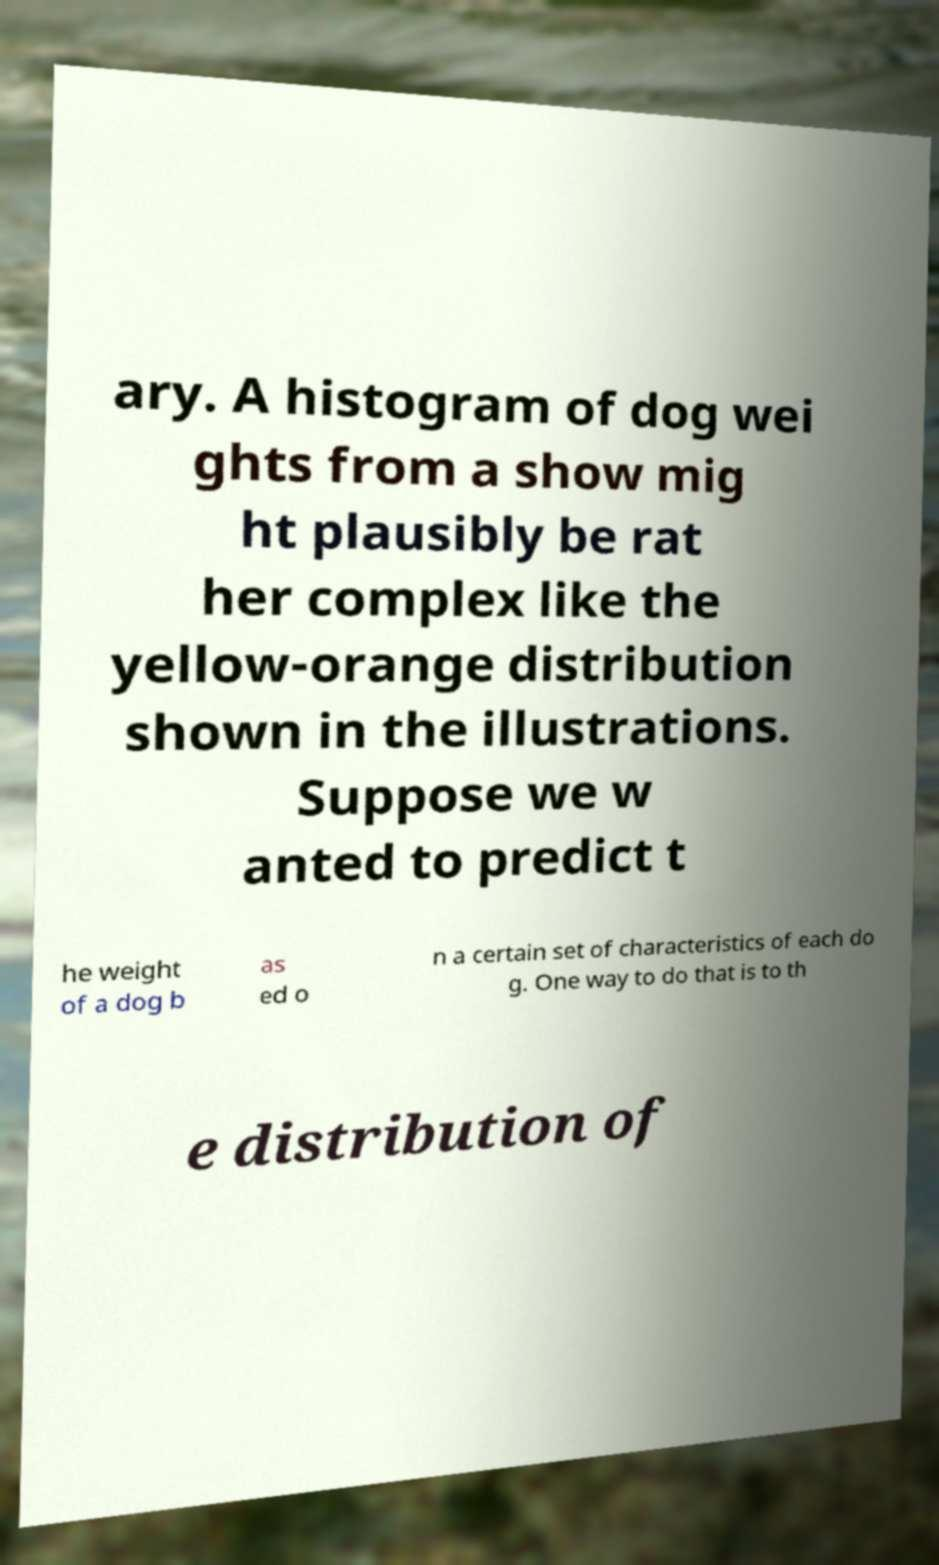I need the written content from this picture converted into text. Can you do that? ary. A histogram of dog wei ghts from a show mig ht plausibly be rat her complex like the yellow-orange distribution shown in the illustrations. Suppose we w anted to predict t he weight of a dog b as ed o n a certain set of characteristics of each do g. One way to do that is to th e distribution of 